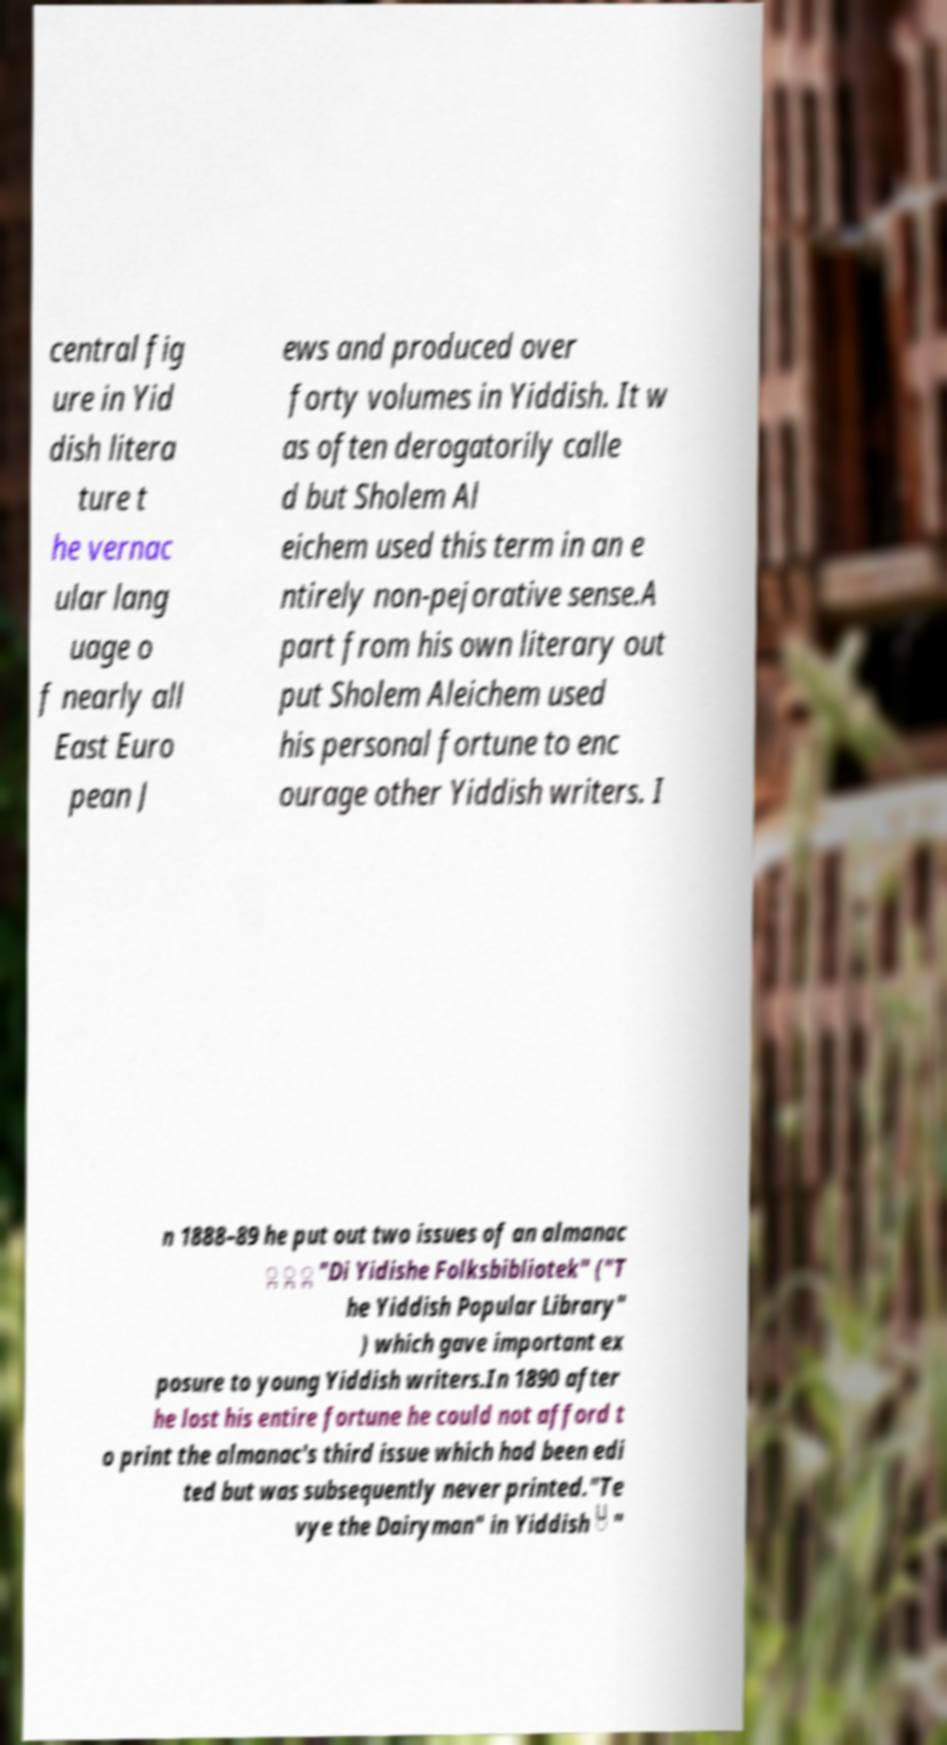Can you read and provide the text displayed in the image?This photo seems to have some interesting text. Can you extract and type it out for me? central fig ure in Yid dish litera ture t he vernac ular lang uage o f nearly all East Euro pean J ews and produced over forty volumes in Yiddish. It w as often derogatorily calle d but Sholem Al eichem used this term in an e ntirely non-pejorative sense.A part from his own literary out put Sholem Aleichem used his personal fortune to enc ourage other Yiddish writers. I n 1888–89 he put out two issues of an almanac ִ ָ ָ "Di Yidishe Folksbibliotek" ("T he Yiddish Popular Library" ) which gave important ex posure to young Yiddish writers.In 1890 after he lost his entire fortune he could not afford t o print the almanac's third issue which had been edi ted but was subsequently never printed."Te vye the Dairyman" in Yiddish ֿ " 